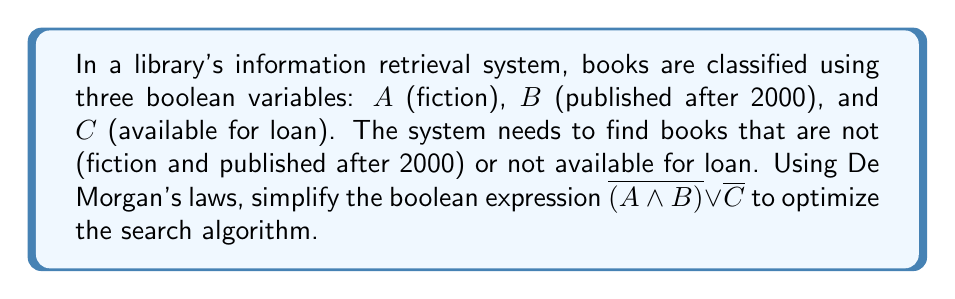Teach me how to tackle this problem. Let's apply De Morgan's laws to simplify the given expression:

1. Start with the original expression:
   $$\overline{(A \land B)} \lor \overline{C}$$

2. Apply De Morgan's first law to the term $\overline{(A \land B)}$:
   De Morgan's first law states that $\overline{(X \land Y)} = \overline{X} \lor \overline{Y}$
   So, $\overline{(A \land B)} = \overline{A} \lor \overline{B}$

3. Substitute this result back into the original expression:
   $$(\overline{A} \lor \overline{B}) \lor \overline{C}$$

4. Use the associative property of OR to regroup:
   $$\overline{A} \lor \overline{B} \lor \overline{C}$$

This simplified expression means the system should retrieve books that are either:
- Not fiction ($\overline{A}$), or
- Not published after 2000 ($\overline{B}$), or
- Not available for loan ($\overline{C}$)

This optimization allows the system to perform three simple checks instead of a compound check followed by an OR operation, potentially improving the efficiency of the search algorithm.
Answer: $\overline{A} \lor \overline{B} \lor \overline{C}$ 